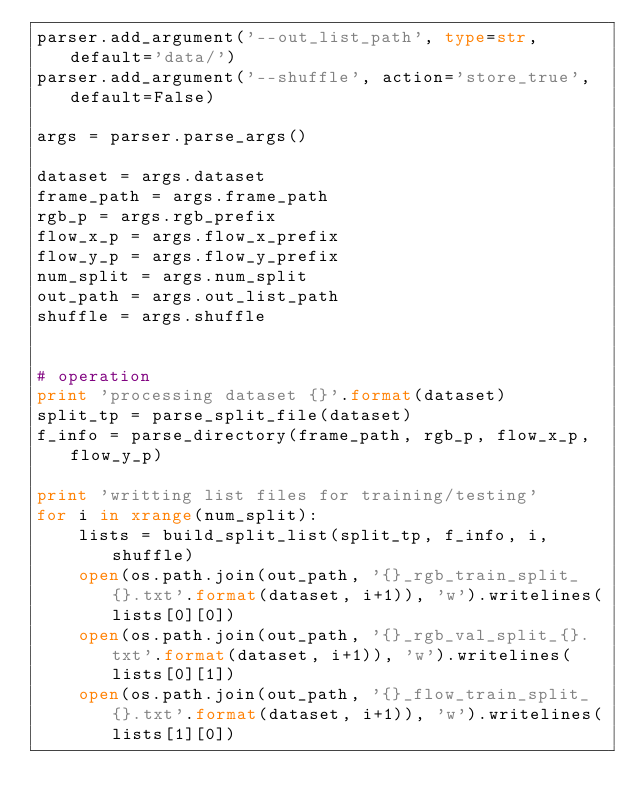<code> <loc_0><loc_0><loc_500><loc_500><_Python_>parser.add_argument('--out_list_path', type=str, default='data/')
parser.add_argument('--shuffle', action='store_true', default=False)

args = parser.parse_args()

dataset = args.dataset
frame_path = args.frame_path
rgb_p = args.rgb_prefix
flow_x_p = args.flow_x_prefix
flow_y_p = args.flow_y_prefix
num_split = args.num_split
out_path = args.out_list_path
shuffle = args.shuffle


# operation
print 'processing dataset {}'.format(dataset)
split_tp = parse_split_file(dataset)
f_info = parse_directory(frame_path, rgb_p, flow_x_p, flow_y_p)

print 'writting list files for training/testing'
for i in xrange(num_split):
    lists = build_split_list(split_tp, f_info, i, shuffle)
    open(os.path.join(out_path, '{}_rgb_train_split_{}.txt'.format(dataset, i+1)), 'w').writelines(lists[0][0])
    open(os.path.join(out_path, '{}_rgb_val_split_{}.txt'.format(dataset, i+1)), 'w').writelines(lists[0][1])
    open(os.path.join(out_path, '{}_flow_train_split_{}.txt'.format(dataset, i+1)), 'w').writelines(lists[1][0])</code> 